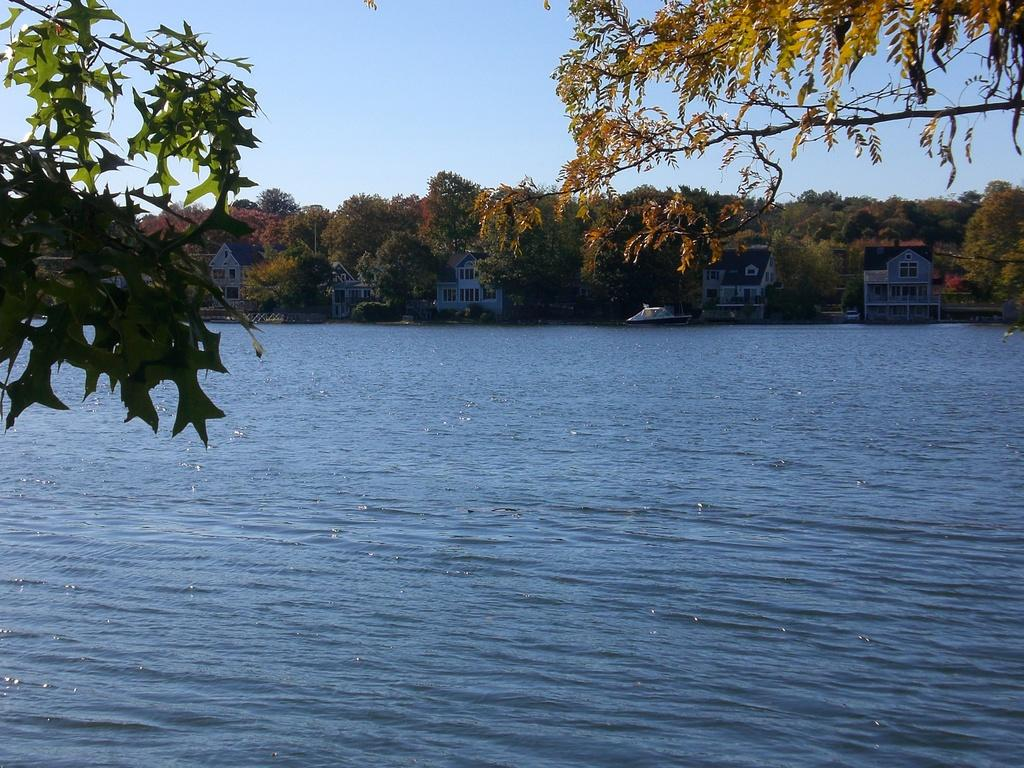What type of natural feature is present in the image? There is a river in the image. How is the water in the river moving? The water in the river is flowing. What is on the water in the image? There is a boat on the water. What type of structures can be seen near the river? There are houses with windows in the image. What type of vegetation is present in the image? There are trees with branches and leaves in the image. What type of badge can be seen on the trees in the image? There are no badges present on the trees in the image. What type of invention is being used to control the flow of the river in the image? There is no invention depicted in the image to control the flow of the river. 